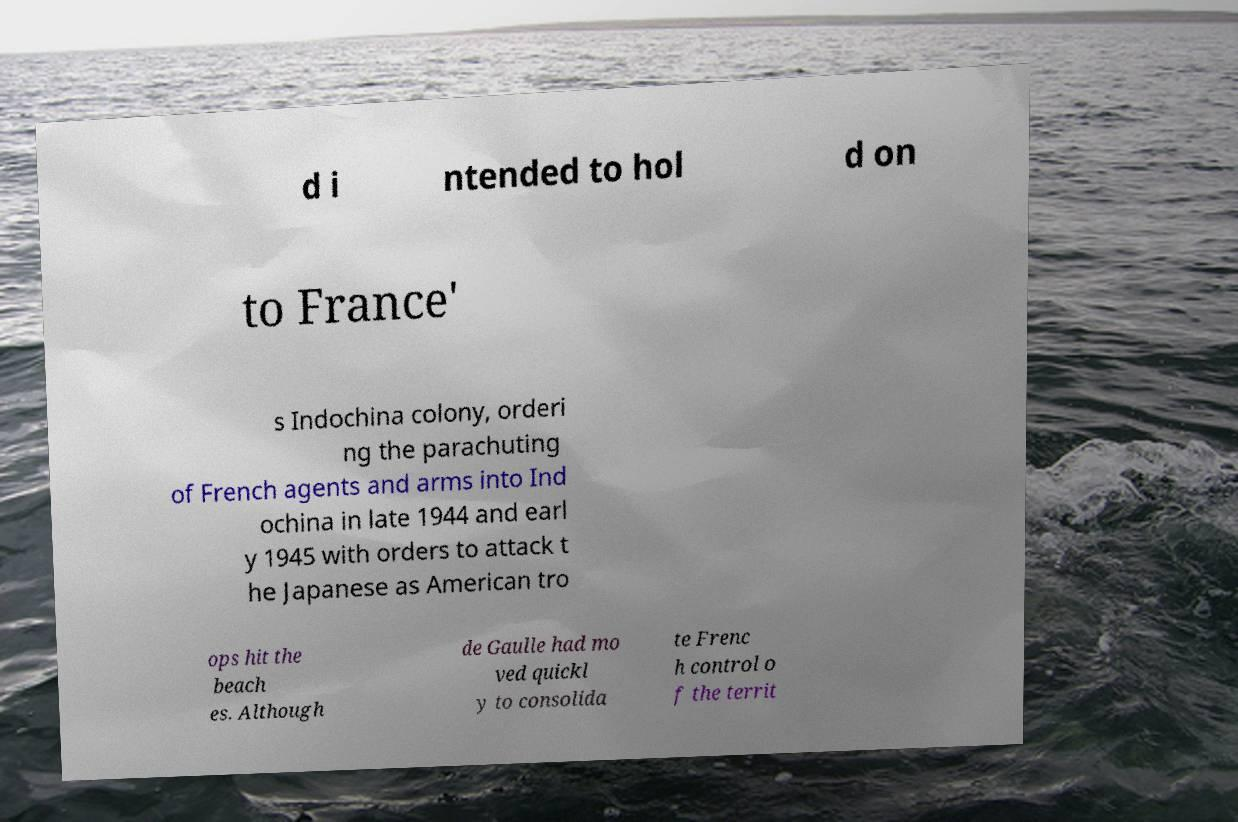Can you read and provide the text displayed in the image?This photo seems to have some interesting text. Can you extract and type it out for me? d i ntended to hol d on to France' s Indochina colony, orderi ng the parachuting of French agents and arms into Ind ochina in late 1944 and earl y 1945 with orders to attack t he Japanese as American tro ops hit the beach es. Although de Gaulle had mo ved quickl y to consolida te Frenc h control o f the territ 